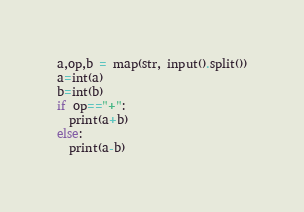<code> <loc_0><loc_0><loc_500><loc_500><_Python_>a,op,b = map(str, input().split())
a=int(a)
b=int(b)
if op=="+":
  print(a+b)
else:
  print(a-b)</code> 